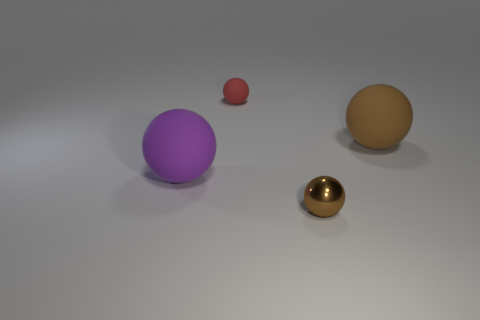How big is the brown sphere that is to the left of the brown ball to the right of the small brown shiny sphere?
Give a very brief answer. Small. What material is the brown sphere that is the same size as the red matte object?
Your answer should be very brief. Metal. Is there a purple sphere made of the same material as the big brown ball?
Your answer should be very brief. Yes. The rubber object that is in front of the big matte object that is on the right side of the object that is in front of the purple sphere is what color?
Provide a succinct answer. Purple. There is a tiny sphere that is on the right side of the small red matte thing; does it have the same color as the object to the left of the red rubber thing?
Make the answer very short. No. Is there anything else of the same color as the tiny metallic ball?
Your answer should be very brief. Yes. Are there fewer small matte things to the right of the big brown rubber sphere than rubber balls?
Keep it short and to the point. Yes. How many small red matte cylinders are there?
Offer a very short reply. 0. There is a tiny brown shiny object; does it have the same shape as the rubber object in front of the big brown sphere?
Provide a short and direct response. Yes. Are there fewer brown shiny objects on the left side of the brown shiny object than tiny red objects on the right side of the tiny red ball?
Offer a very short reply. No. 